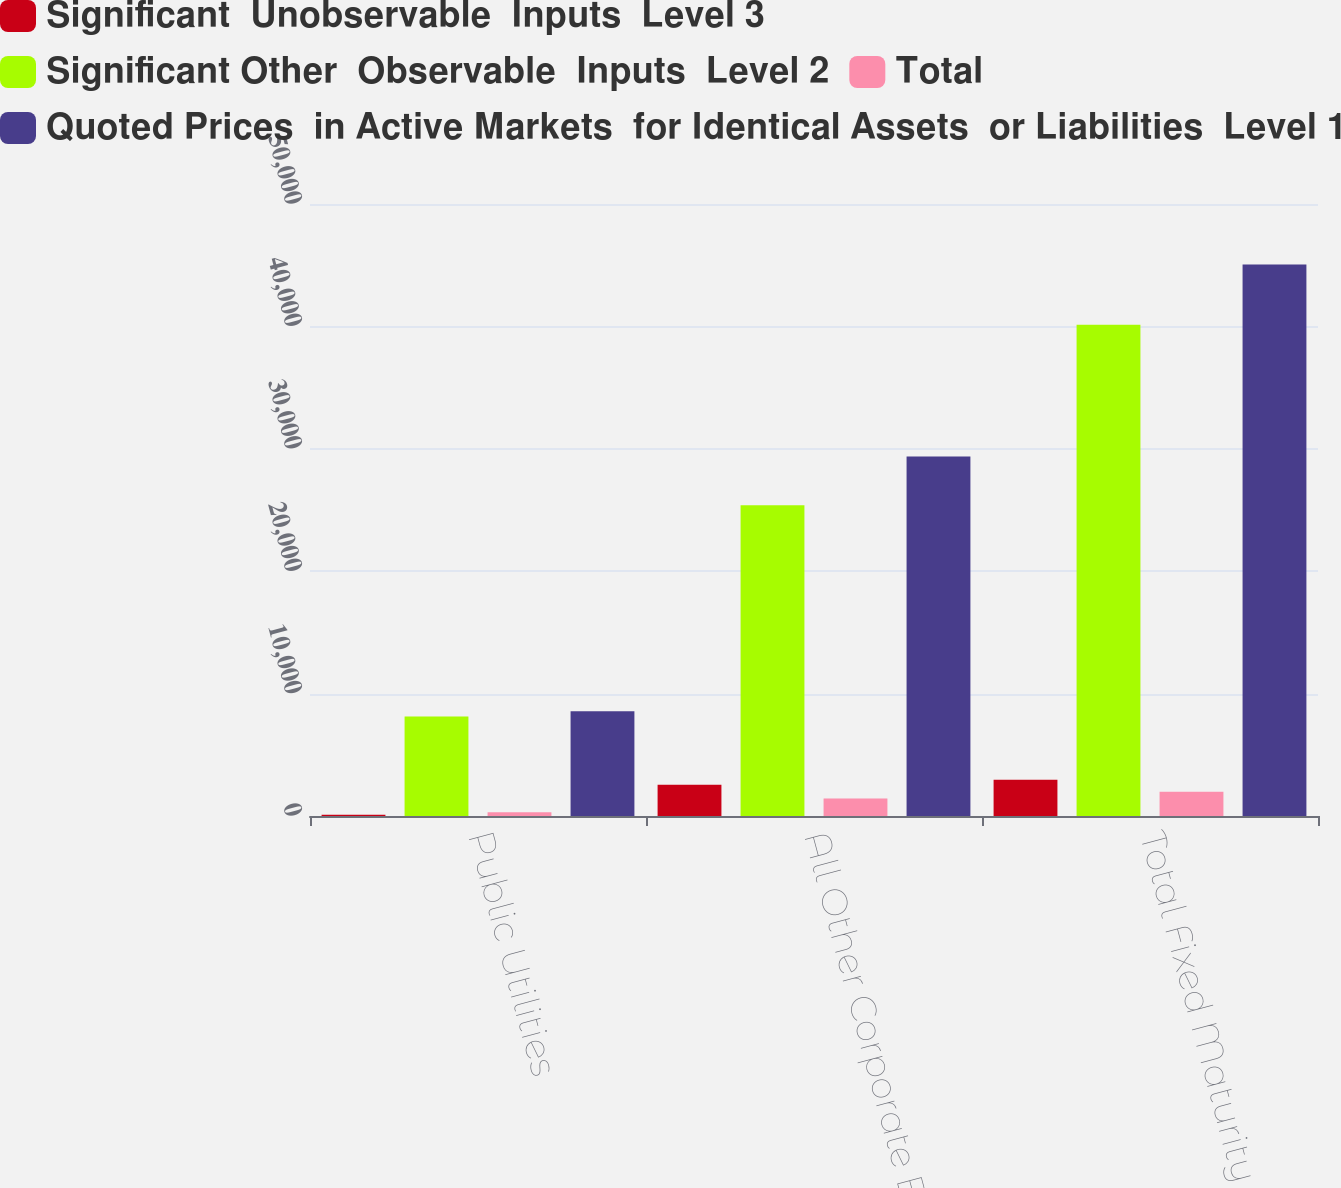Convert chart to OTSL. <chart><loc_0><loc_0><loc_500><loc_500><stacked_bar_chart><ecel><fcel>Public Utilities<fcel>All Other Corporate Bonds<fcel>Total Fixed Maturity<nl><fcel>Significant  Unobservable  Inputs  Level 3<fcel>106.2<fcel>2556.6<fcel>2960.3<nl><fcel>Significant Other  Observable  Inputs  Level 2<fcel>8129.4<fcel>25383.3<fcel>40130<nl><fcel>Total<fcel>315<fcel>1425.3<fcel>1974.6<nl><fcel>Quoted Prices  in Active Markets  for Identical Assets  or Liabilities  Level 1<fcel>8550.6<fcel>29365.2<fcel>45064.9<nl></chart> 